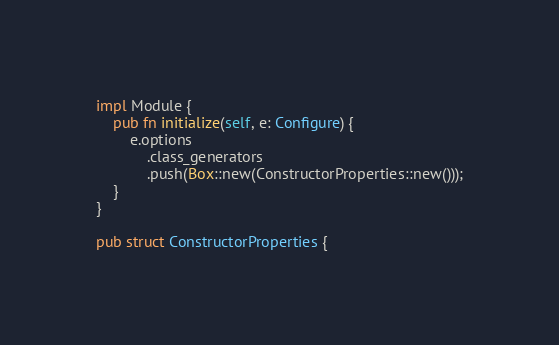Convert code to text. <code><loc_0><loc_0><loc_500><loc_500><_Rust_>impl Module {
    pub fn initialize(self, e: Configure) {
        e.options
            .class_generators
            .push(Box::new(ConstructorProperties::new()));
    }
}

pub struct ConstructorProperties {</code> 